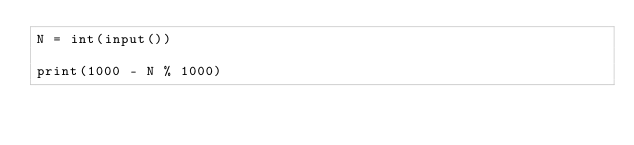<code> <loc_0><loc_0><loc_500><loc_500><_Python_>N = int(input())

print(1000 - N % 1000)
</code> 